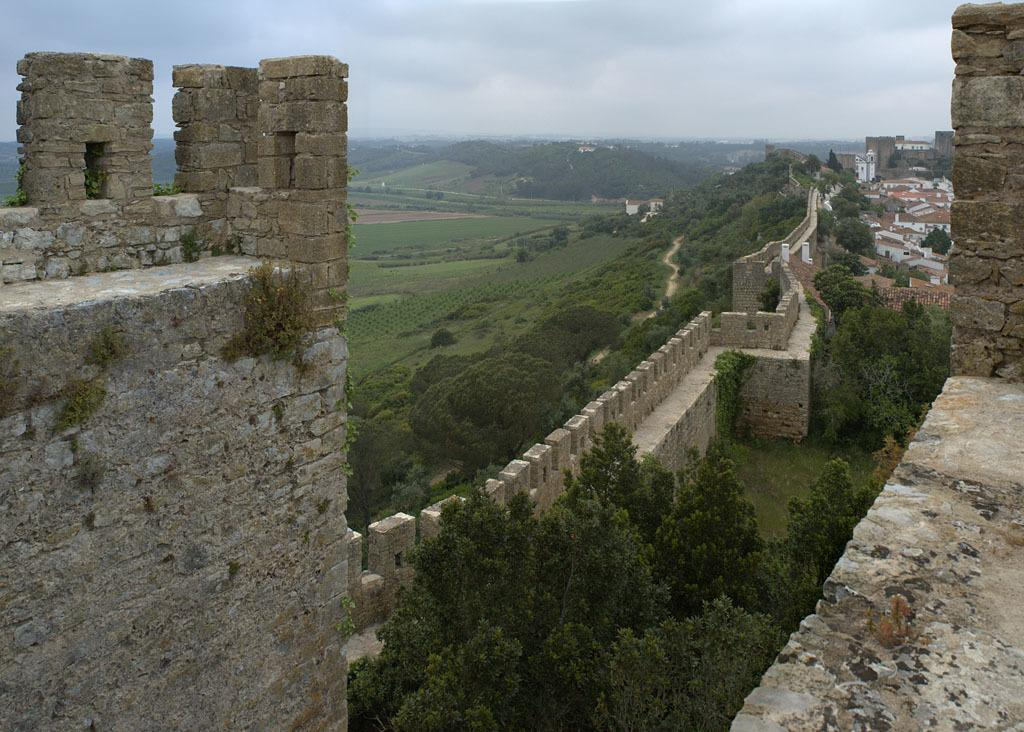What type of natural elements can be seen in the image? There are trees in the image. What type of man-made structures are present in the image? There are walls in the image. What other items or objects can be seen in the image? There are some objects in the image. What is visible in the background of the image? The sky is visible in the background of the image. How many trains are visible in the image? There are no trains present in the image. What type of place is depicted in the image? The image does not depict a specific place; it only shows trees, walls, objects, and the sky. 